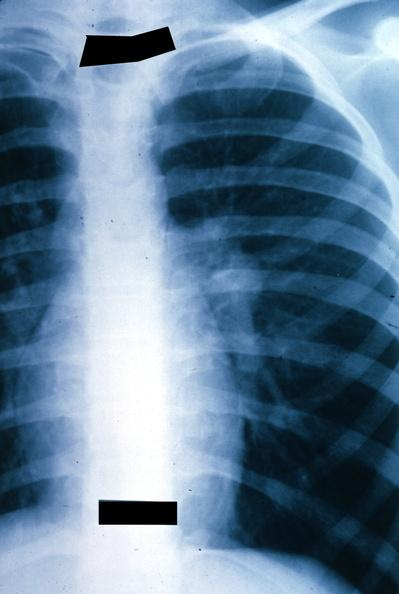s metastatic malignant ependymoma present?
Answer the question using a single word or phrase. Yes 